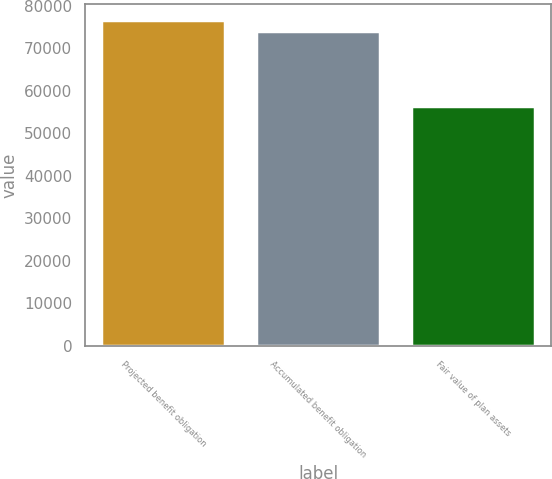<chart> <loc_0><loc_0><loc_500><loc_500><bar_chart><fcel>Projected benefit obligation<fcel>Accumulated benefit obligation<fcel>Fair value of plan assets<nl><fcel>76586<fcel>74081<fcel>56530<nl></chart> 